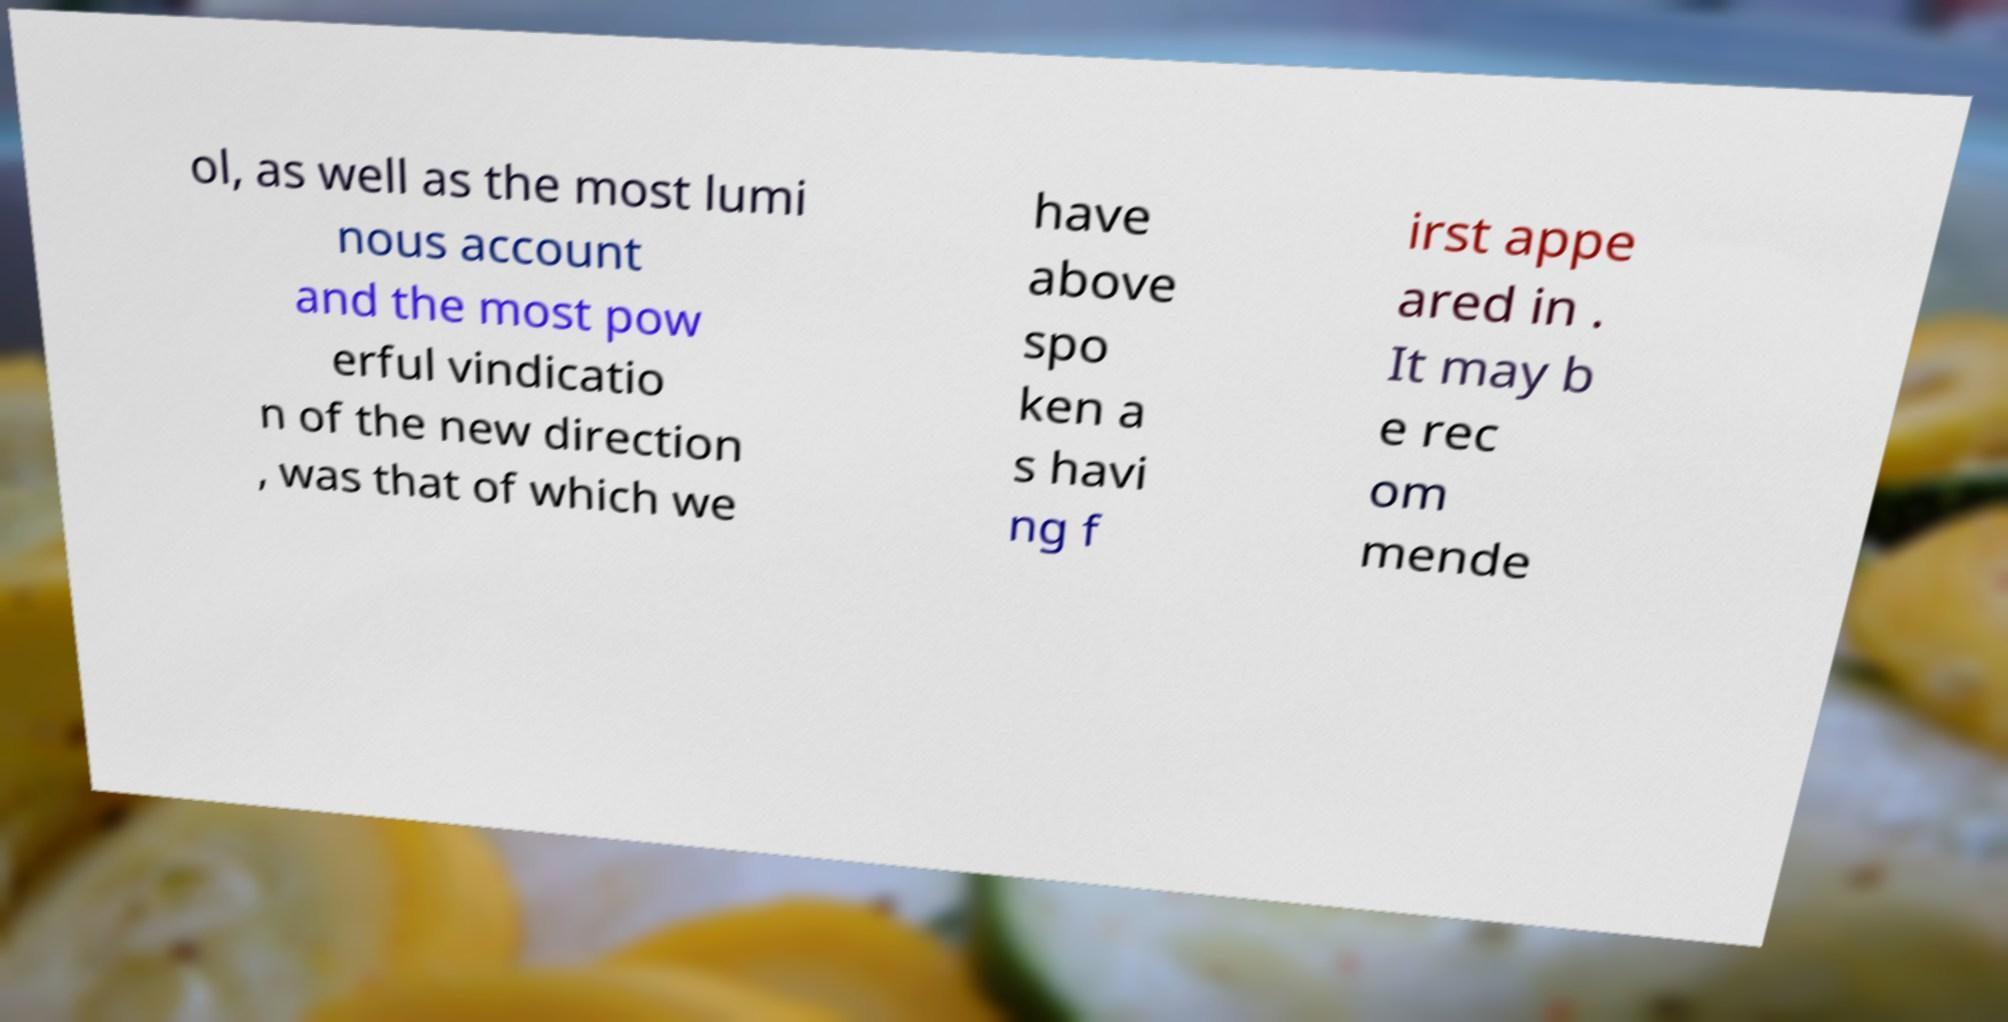Could you assist in decoding the text presented in this image and type it out clearly? ol, as well as the most lumi nous account and the most pow erful vindicatio n of the new direction , was that of which we have above spo ken a s havi ng f irst appe ared in . It may b e rec om mende 